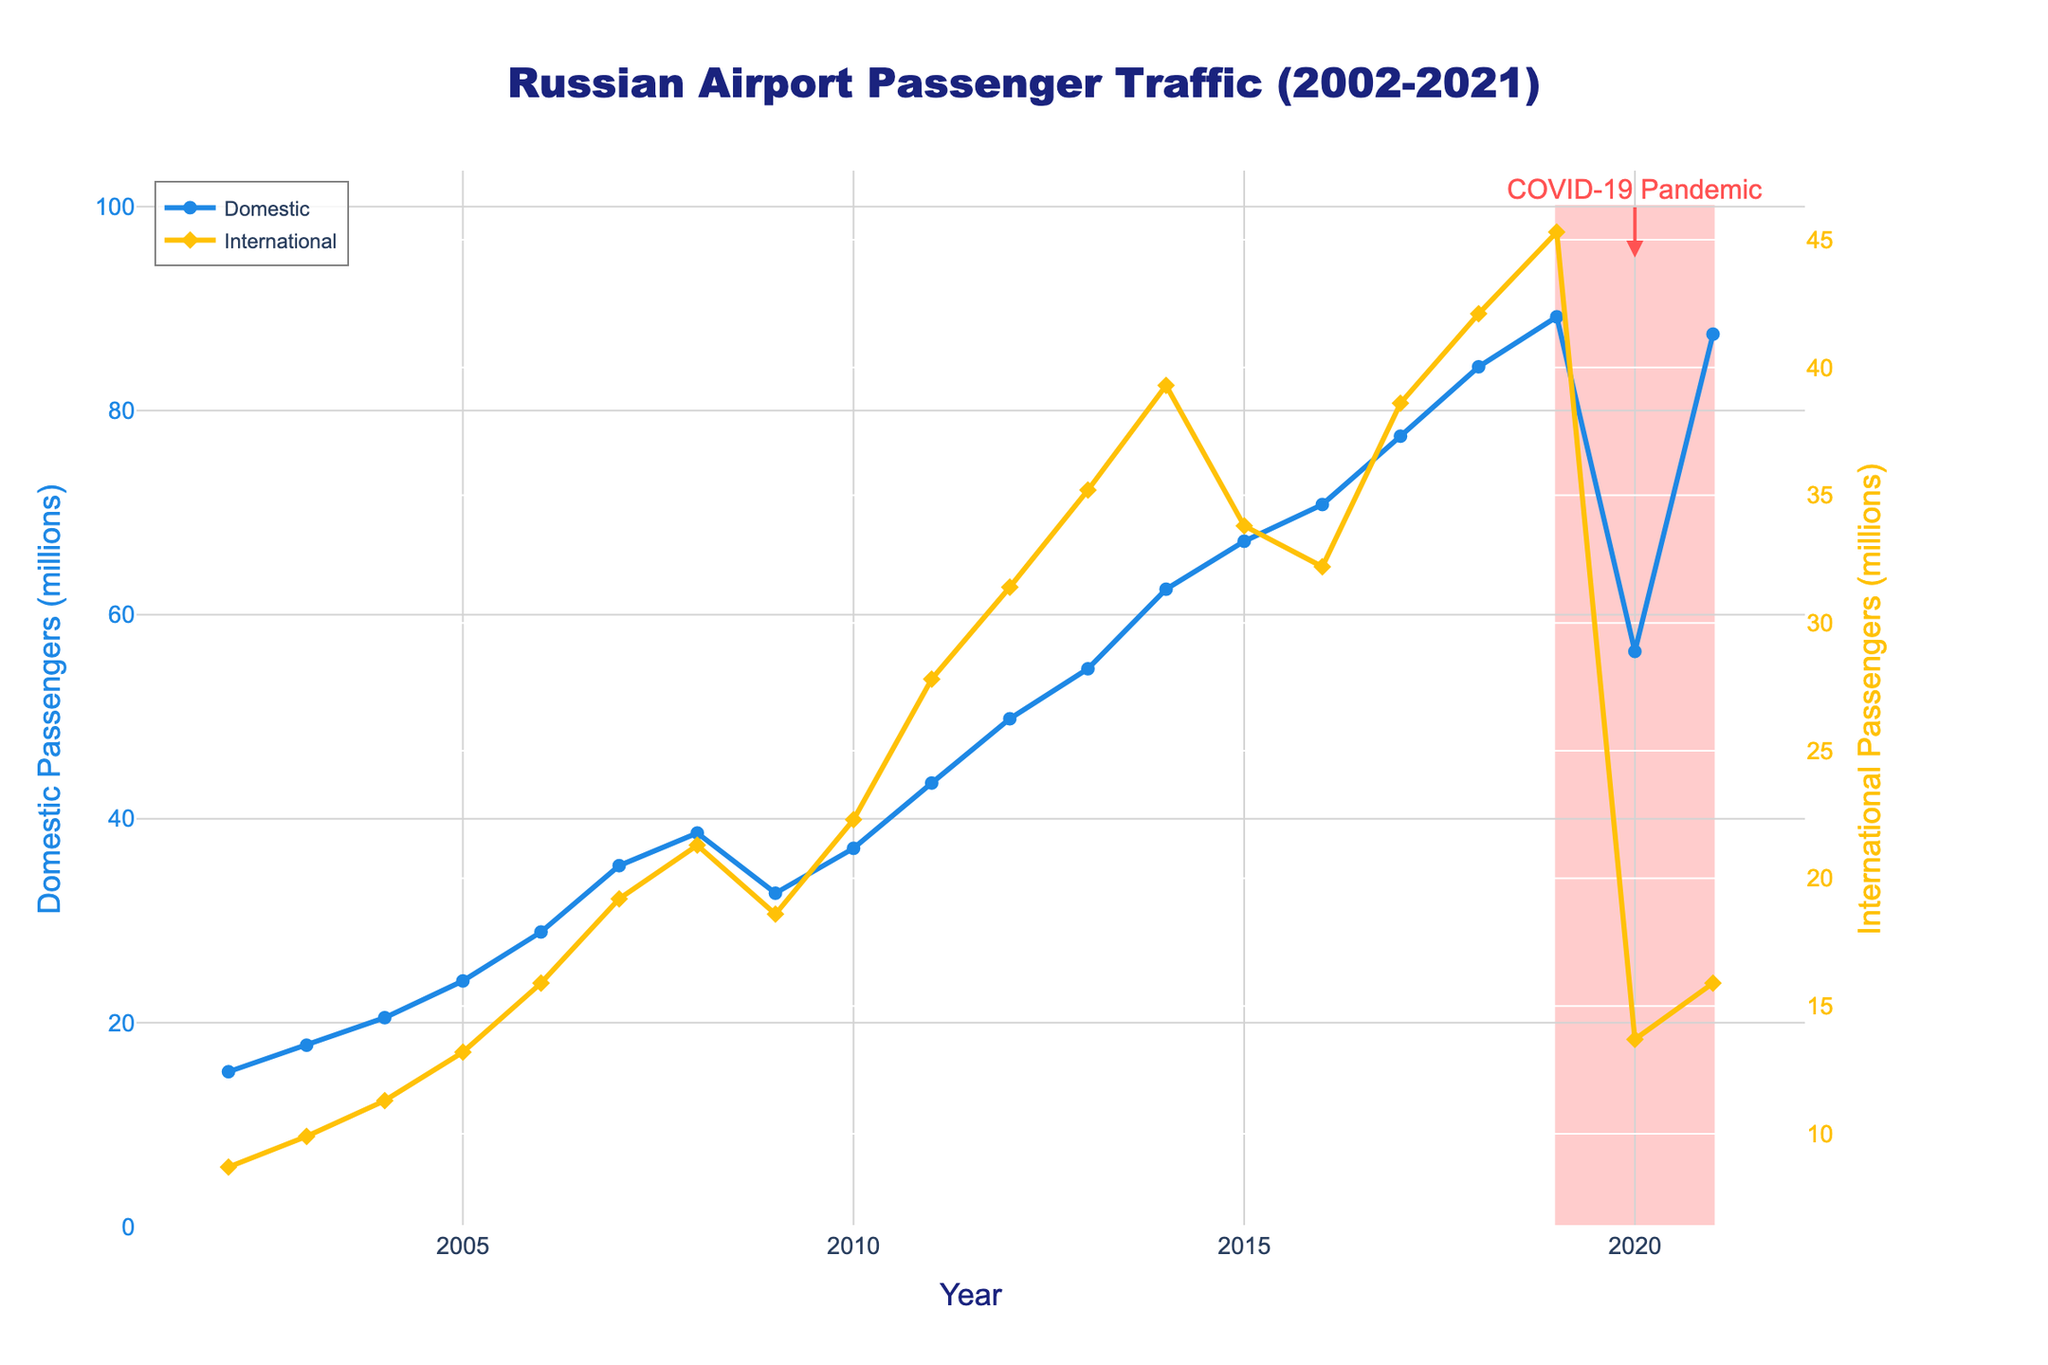How did the number of domestic passengers change from 2008 to 2009? The number of domestic passengers decreased from 38.6 million in 2008 to 32.7 million in 2009. The change can be calculated as 38.6 - 32.7 = 5.9 million.
Answer: Decreased by 5.9 million What is the average number of international passengers from 2015 to 2018? To find the average, sum the number of international passengers from 2015 to 2018: 33.8 + 32.2 + 38.6 + 42.1 = 146.7 million. Divide this sum by the number of years, which is 4. 146.7 / 4 = 36.675 million.
Answer: 36.675 million Which year saw the highest number of domestic passengers? By looking at the figure, the highest number of domestic passengers occurred in 2019, with 89.2 million passengers.
Answer: 2019 What was the impact of the COVID-19 pandemic on international passenger traffic? The red shaded area highlights the impact period of the COVID-19 pandemic, showing a dramatic drop in international passengers in 2020 to 13.7 million from 45.3 million in 2019.
Answer: Significant decrease Compare the domestic passenger traffic in 2011 to that in 2021. What difference do you find? In 2011, there were 43.5 million domestic passengers, and in 2021, there were 87.5 million. The difference is 87.5 - 43.5 = 44 million more passengers in 2021.
Answer: 44 million more in 2021 Identify the year with the least international passengers and state the amount. The year with the least international passengers is 2020, with 13.7 million passengers.
Answer: 2020, 13.7 million By how much did the number of international passengers increase from 2005 to 2012? The number of international passengers increased from 13.2 million in 2005 to 31.4 million in 2012. The increase is 31.4 - 13.2 = 18.2 million.
Answer: Increased by 18.2 million What trend do you observe in domestic passenger traffic between 2002 and 2019? The domestic passenger traffic shows a general increasing trend from 15.2 million in 2002 to 89.2 million in 2019, with some fluctuations in between.
Answer: Increasing trend How did the number of international passengers in 2021 compare to the pre-pandemic year 2019? In 2019, there were 45.3 million international passengers, while in 2021, there were 15.9 million. The number in 2021 is significantly lower.
Answer: Significantly lower in 2021 What is the total number of passengers (domestic and international) for the year 2018? The total number of passengers in 2018 is the sum of domestic and international passengers: 84.3 million (domestic) + 42.1 million (international) = 126.4 million.
Answer: 126.4 million 